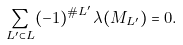<formula> <loc_0><loc_0><loc_500><loc_500>\sum _ { L ^ { \prime } \subset L } ( - 1 ) ^ { \# L ^ { \prime } } \lambda ( M _ { L ^ { \prime } } ) = 0 .</formula> 